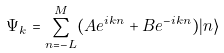<formula> <loc_0><loc_0><loc_500><loc_500>\Psi _ { k } = \sum _ { n = - L } ^ { M } ( A e ^ { i k n } + B e ^ { - i k n } ) | n \rangle</formula> 